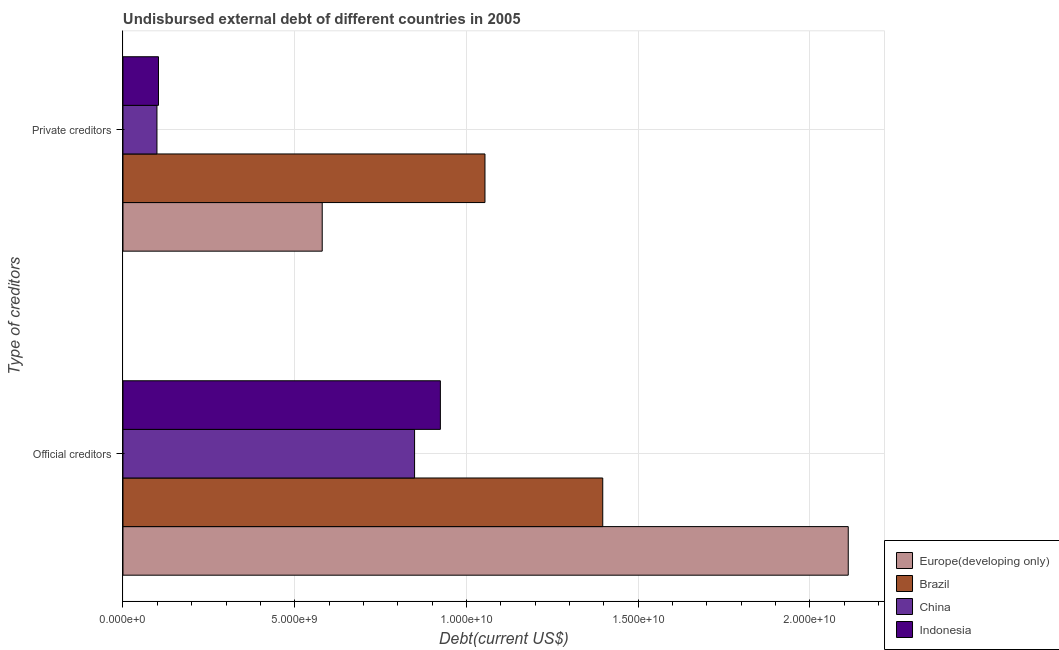How many different coloured bars are there?
Offer a terse response. 4. What is the label of the 1st group of bars from the top?
Ensure brevity in your answer.  Private creditors. What is the undisbursed external debt of private creditors in Europe(developing only)?
Provide a succinct answer. 5.80e+09. Across all countries, what is the maximum undisbursed external debt of official creditors?
Provide a short and direct response. 2.11e+1. Across all countries, what is the minimum undisbursed external debt of official creditors?
Make the answer very short. 8.49e+09. In which country was the undisbursed external debt of private creditors maximum?
Your response must be concise. Brazil. What is the total undisbursed external debt of official creditors in the graph?
Make the answer very short. 5.28e+1. What is the difference between the undisbursed external debt of official creditors in Indonesia and that in Brazil?
Your answer should be very brief. -4.73e+09. What is the difference between the undisbursed external debt of private creditors in Europe(developing only) and the undisbursed external debt of official creditors in Brazil?
Offer a very short reply. -8.17e+09. What is the average undisbursed external debt of official creditors per country?
Keep it short and to the point. 1.32e+1. What is the difference between the undisbursed external debt of official creditors and undisbursed external debt of private creditors in Brazil?
Give a very brief answer. 3.43e+09. What is the ratio of the undisbursed external debt of private creditors in Indonesia to that in Brazil?
Your answer should be very brief. 0.1. What is the difference between two consecutive major ticks on the X-axis?
Provide a succinct answer. 5.00e+09. Are the values on the major ticks of X-axis written in scientific E-notation?
Offer a terse response. Yes. Does the graph contain grids?
Keep it short and to the point. Yes. Where does the legend appear in the graph?
Ensure brevity in your answer.  Bottom right. How are the legend labels stacked?
Ensure brevity in your answer.  Vertical. What is the title of the graph?
Your response must be concise. Undisbursed external debt of different countries in 2005. What is the label or title of the X-axis?
Provide a short and direct response. Debt(current US$). What is the label or title of the Y-axis?
Your answer should be compact. Type of creditors. What is the Debt(current US$) of Europe(developing only) in Official creditors?
Keep it short and to the point. 2.11e+1. What is the Debt(current US$) of Brazil in Official creditors?
Keep it short and to the point. 1.40e+1. What is the Debt(current US$) of China in Official creditors?
Your response must be concise. 8.49e+09. What is the Debt(current US$) of Indonesia in Official creditors?
Your response must be concise. 9.24e+09. What is the Debt(current US$) of Europe(developing only) in Private creditors?
Your answer should be very brief. 5.80e+09. What is the Debt(current US$) in Brazil in Private creditors?
Your answer should be very brief. 1.05e+1. What is the Debt(current US$) in China in Private creditors?
Offer a very short reply. 9.89e+08. What is the Debt(current US$) of Indonesia in Private creditors?
Provide a short and direct response. 1.03e+09. Across all Type of creditors, what is the maximum Debt(current US$) in Europe(developing only)?
Ensure brevity in your answer.  2.11e+1. Across all Type of creditors, what is the maximum Debt(current US$) of Brazil?
Provide a short and direct response. 1.40e+1. Across all Type of creditors, what is the maximum Debt(current US$) in China?
Offer a terse response. 8.49e+09. Across all Type of creditors, what is the maximum Debt(current US$) in Indonesia?
Your response must be concise. 9.24e+09. Across all Type of creditors, what is the minimum Debt(current US$) of Europe(developing only)?
Ensure brevity in your answer.  5.80e+09. Across all Type of creditors, what is the minimum Debt(current US$) of Brazil?
Make the answer very short. 1.05e+1. Across all Type of creditors, what is the minimum Debt(current US$) of China?
Your answer should be compact. 9.89e+08. Across all Type of creditors, what is the minimum Debt(current US$) of Indonesia?
Your answer should be very brief. 1.03e+09. What is the total Debt(current US$) in Europe(developing only) in the graph?
Offer a terse response. 2.69e+1. What is the total Debt(current US$) of Brazil in the graph?
Your answer should be compact. 2.45e+1. What is the total Debt(current US$) of China in the graph?
Your answer should be compact. 9.48e+09. What is the total Debt(current US$) of Indonesia in the graph?
Your answer should be very brief. 1.03e+1. What is the difference between the Debt(current US$) of Europe(developing only) in Official creditors and that in Private creditors?
Your answer should be very brief. 1.53e+1. What is the difference between the Debt(current US$) of Brazil in Official creditors and that in Private creditors?
Your response must be concise. 3.43e+09. What is the difference between the Debt(current US$) in China in Official creditors and that in Private creditors?
Your answer should be compact. 7.50e+09. What is the difference between the Debt(current US$) in Indonesia in Official creditors and that in Private creditors?
Your answer should be compact. 8.21e+09. What is the difference between the Debt(current US$) of Europe(developing only) in Official creditors and the Debt(current US$) of Brazil in Private creditors?
Your answer should be compact. 1.06e+1. What is the difference between the Debt(current US$) of Europe(developing only) in Official creditors and the Debt(current US$) of China in Private creditors?
Ensure brevity in your answer.  2.01e+1. What is the difference between the Debt(current US$) in Europe(developing only) in Official creditors and the Debt(current US$) in Indonesia in Private creditors?
Provide a short and direct response. 2.01e+1. What is the difference between the Debt(current US$) of Brazil in Official creditors and the Debt(current US$) of China in Private creditors?
Offer a terse response. 1.30e+1. What is the difference between the Debt(current US$) of Brazil in Official creditors and the Debt(current US$) of Indonesia in Private creditors?
Make the answer very short. 1.29e+1. What is the difference between the Debt(current US$) of China in Official creditors and the Debt(current US$) of Indonesia in Private creditors?
Offer a terse response. 7.46e+09. What is the average Debt(current US$) in Europe(developing only) per Type of creditors?
Your response must be concise. 1.35e+1. What is the average Debt(current US$) in Brazil per Type of creditors?
Your response must be concise. 1.23e+1. What is the average Debt(current US$) in China per Type of creditors?
Offer a very short reply. 4.74e+09. What is the average Debt(current US$) in Indonesia per Type of creditors?
Your answer should be very brief. 5.14e+09. What is the difference between the Debt(current US$) in Europe(developing only) and Debt(current US$) in Brazil in Official creditors?
Your answer should be very brief. 7.15e+09. What is the difference between the Debt(current US$) of Europe(developing only) and Debt(current US$) of China in Official creditors?
Your response must be concise. 1.26e+1. What is the difference between the Debt(current US$) of Europe(developing only) and Debt(current US$) of Indonesia in Official creditors?
Your answer should be very brief. 1.19e+1. What is the difference between the Debt(current US$) of Brazil and Debt(current US$) of China in Official creditors?
Provide a succinct answer. 5.48e+09. What is the difference between the Debt(current US$) in Brazil and Debt(current US$) in Indonesia in Official creditors?
Offer a very short reply. 4.73e+09. What is the difference between the Debt(current US$) of China and Debt(current US$) of Indonesia in Official creditors?
Ensure brevity in your answer.  -7.51e+08. What is the difference between the Debt(current US$) of Europe(developing only) and Debt(current US$) of Brazil in Private creditors?
Provide a short and direct response. -4.74e+09. What is the difference between the Debt(current US$) in Europe(developing only) and Debt(current US$) in China in Private creditors?
Provide a short and direct response. 4.81e+09. What is the difference between the Debt(current US$) in Europe(developing only) and Debt(current US$) in Indonesia in Private creditors?
Offer a very short reply. 4.77e+09. What is the difference between the Debt(current US$) in Brazil and Debt(current US$) in China in Private creditors?
Offer a very short reply. 9.55e+09. What is the difference between the Debt(current US$) in Brazil and Debt(current US$) in Indonesia in Private creditors?
Make the answer very short. 9.50e+09. What is the difference between the Debt(current US$) of China and Debt(current US$) of Indonesia in Private creditors?
Keep it short and to the point. -4.46e+07. What is the ratio of the Debt(current US$) of Europe(developing only) in Official creditors to that in Private creditors?
Your answer should be very brief. 3.64. What is the ratio of the Debt(current US$) in Brazil in Official creditors to that in Private creditors?
Offer a very short reply. 1.33. What is the ratio of the Debt(current US$) in China in Official creditors to that in Private creditors?
Provide a succinct answer. 8.58. What is the ratio of the Debt(current US$) in Indonesia in Official creditors to that in Private creditors?
Ensure brevity in your answer.  8.94. What is the difference between the highest and the second highest Debt(current US$) of Europe(developing only)?
Offer a very short reply. 1.53e+1. What is the difference between the highest and the second highest Debt(current US$) of Brazil?
Provide a succinct answer. 3.43e+09. What is the difference between the highest and the second highest Debt(current US$) in China?
Offer a terse response. 7.50e+09. What is the difference between the highest and the second highest Debt(current US$) of Indonesia?
Give a very brief answer. 8.21e+09. What is the difference between the highest and the lowest Debt(current US$) of Europe(developing only)?
Provide a succinct answer. 1.53e+1. What is the difference between the highest and the lowest Debt(current US$) in Brazil?
Your answer should be very brief. 3.43e+09. What is the difference between the highest and the lowest Debt(current US$) in China?
Offer a terse response. 7.50e+09. What is the difference between the highest and the lowest Debt(current US$) in Indonesia?
Your response must be concise. 8.21e+09. 